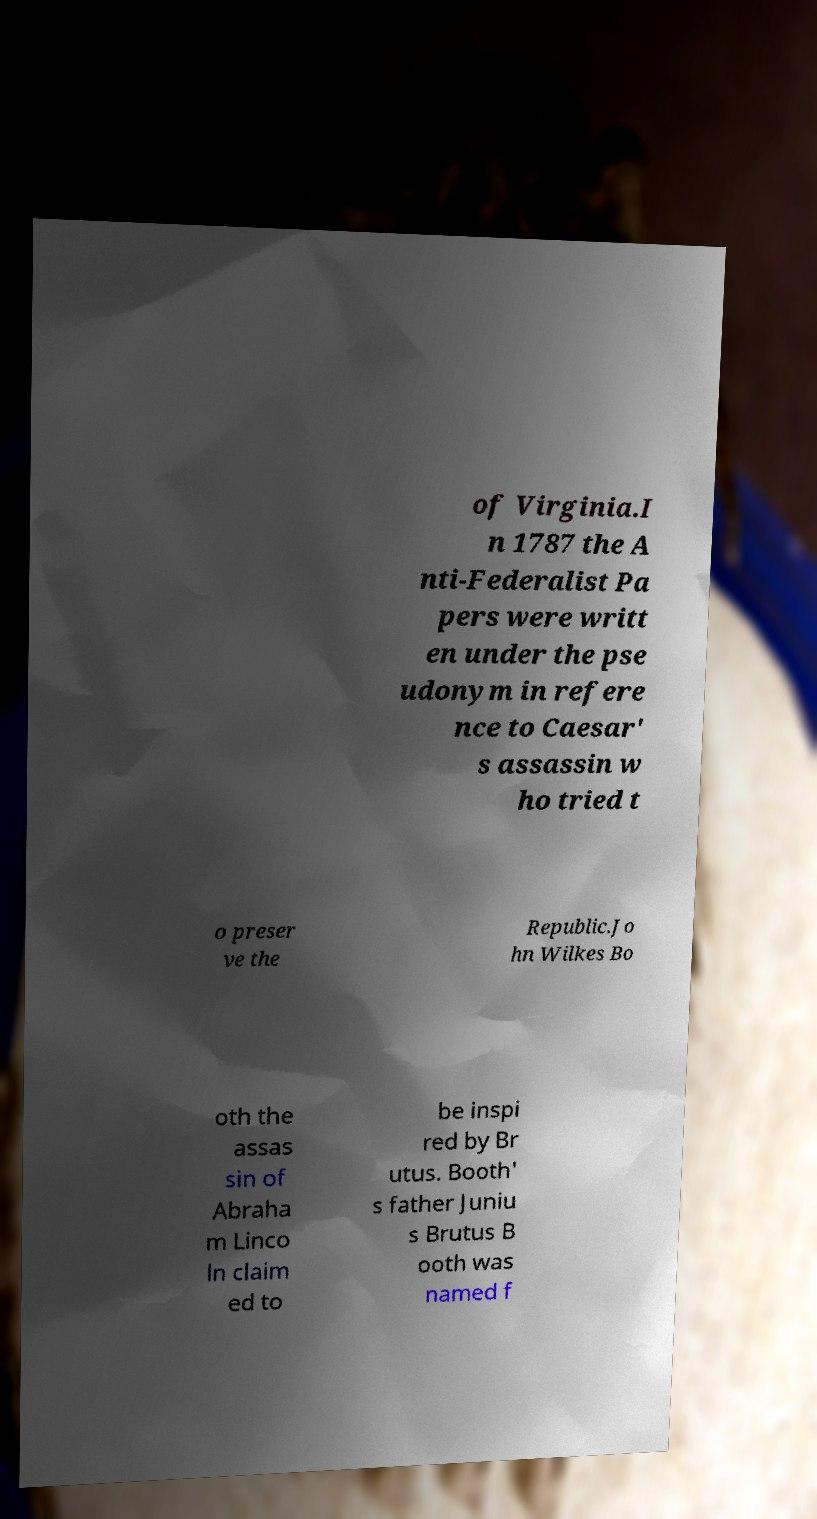For documentation purposes, I need the text within this image transcribed. Could you provide that? of Virginia.I n 1787 the A nti-Federalist Pa pers were writt en under the pse udonym in refere nce to Caesar' s assassin w ho tried t o preser ve the Republic.Jo hn Wilkes Bo oth the assas sin of Abraha m Linco ln claim ed to be inspi red by Br utus. Booth' s father Juniu s Brutus B ooth was named f 